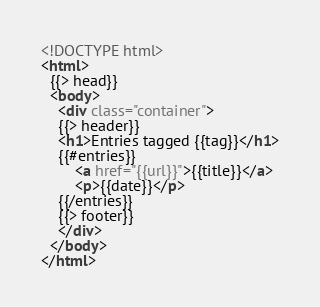<code> <loc_0><loc_0><loc_500><loc_500><_HTML_><!DOCTYPE html>
<html>
  {{> head}}
  <body>
    <div class="container">
    {{> header}}
    <h1>Entries tagged {{tag}}</h1>
    {{#entries}}
        <a href="{{url}}">{{title}}</a>
        <p>{{date}}</p>
    {{/entries}}          
    {{> footer}}
    </div>
  </body>
</html></code> 